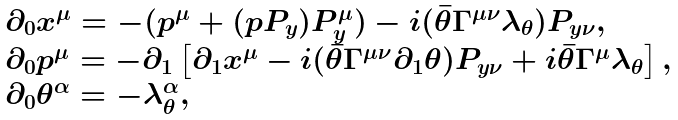Convert formula to latex. <formula><loc_0><loc_0><loc_500><loc_500>\begin{array} { l } { { \quad \partial _ { 0 } x ^ { \mu } = - ( p ^ { \mu } + ( p P _ { y } ) P _ { y } ^ { \mu } ) - i ( \bar { \theta } \Gamma ^ { \mu \nu } \lambda _ { \theta } ) P _ { y \nu } , } } \\ { { \quad \partial _ { 0 } p ^ { \mu } = - \partial _ { 1 } \left [ \partial _ { 1 } x ^ { \mu } - i ( \bar { \theta } \Gamma ^ { \mu \nu } \partial _ { 1 } \theta ) P _ { y \nu } + i \bar { \theta } \Gamma ^ { \mu } \lambda _ { \theta } \right ] , } } \\ { { \quad \partial _ { 0 } \theta ^ { \alpha } = - \lambda _ { \theta } ^ { \alpha } , } } \end{array}</formula> 